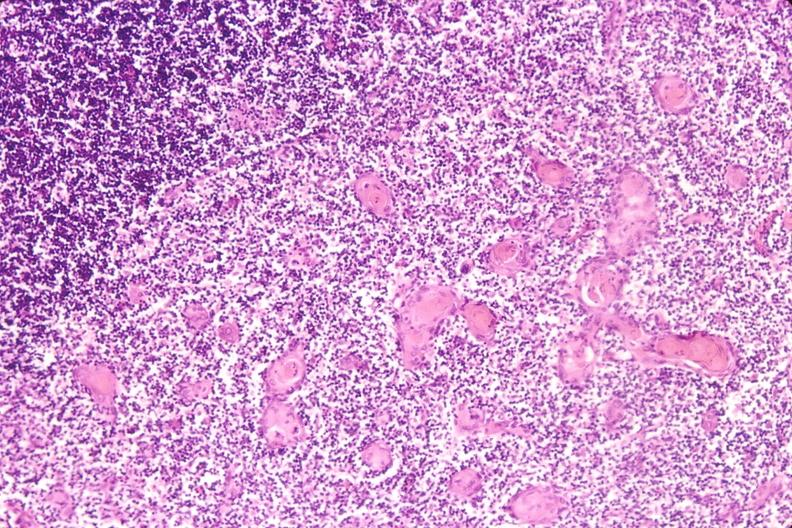what does this image show?
Answer the question using a single word or phrase. Thymus 